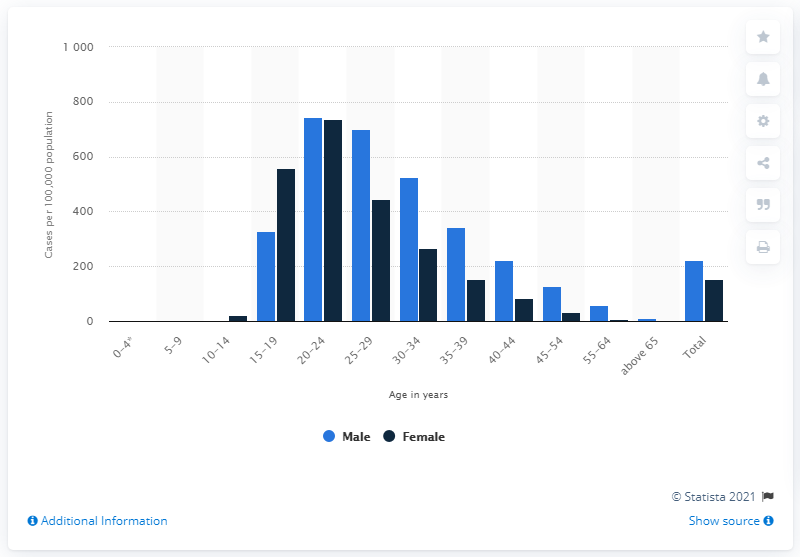Outline some significant characteristics in this image. In the year 2000, the rate of gonorrhea among women between the ages of 20 and 24 was 737.4 cases per 100,000 population. 